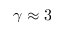Convert formula to latex. <formula><loc_0><loc_0><loc_500><loc_500>\gamma \approx 3</formula> 